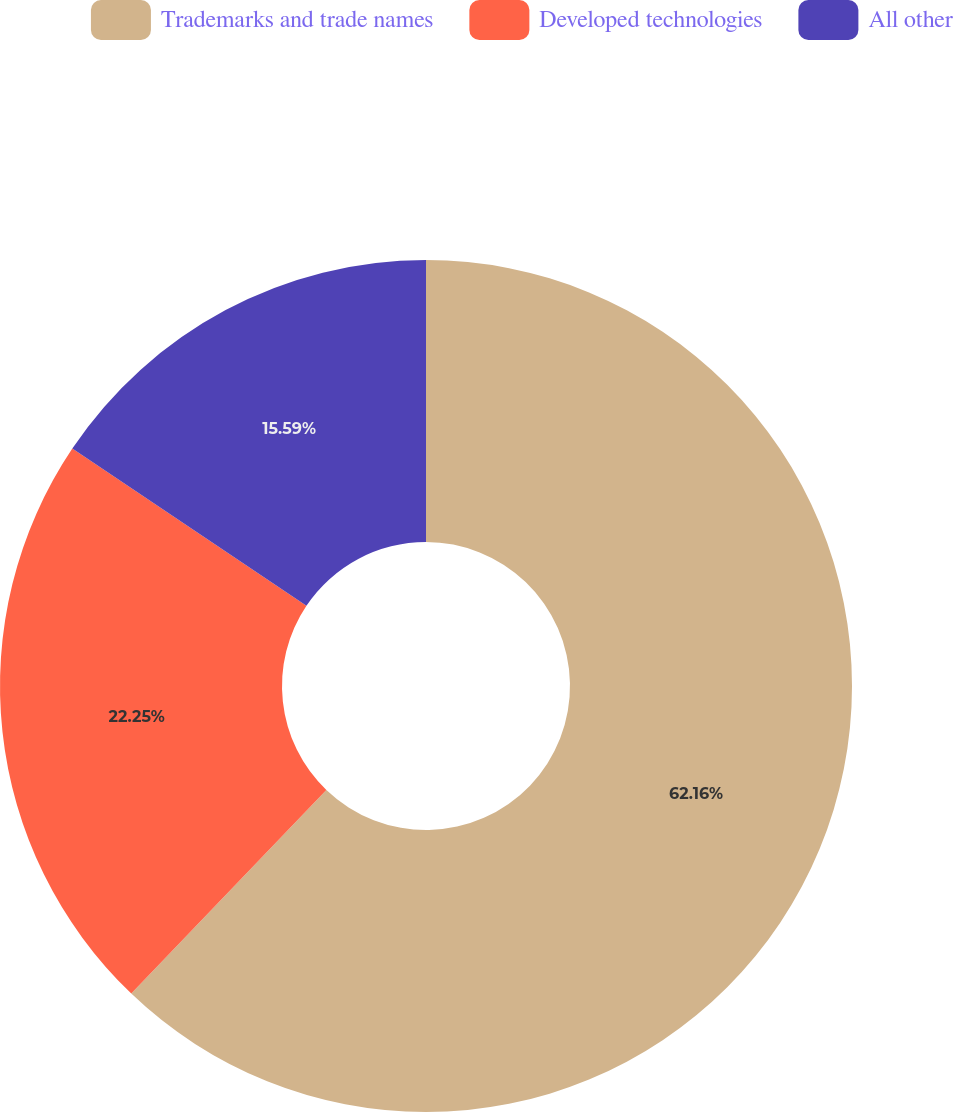<chart> <loc_0><loc_0><loc_500><loc_500><pie_chart><fcel>Trademarks and trade names<fcel>Developed technologies<fcel>All other<nl><fcel>62.16%<fcel>22.25%<fcel>15.59%<nl></chart> 